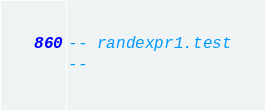Convert code to text. <code><loc_0><loc_0><loc_500><loc_500><_SQL_>-- randexpr1.test
-- </code> 